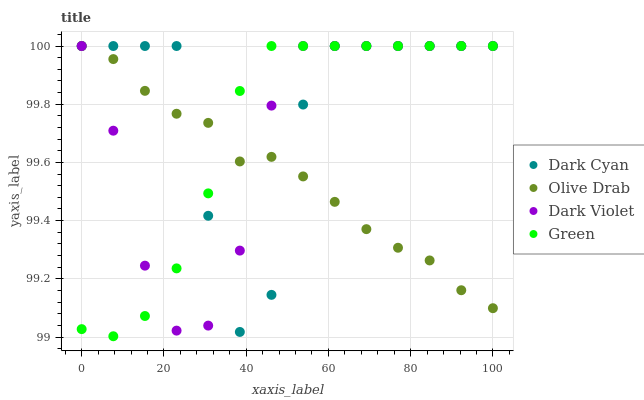Does Olive Drab have the minimum area under the curve?
Answer yes or no. Yes. Does Dark Cyan have the maximum area under the curve?
Answer yes or no. Yes. Does Green have the minimum area under the curve?
Answer yes or no. No. Does Green have the maximum area under the curve?
Answer yes or no. No. Is Olive Drab the smoothest?
Answer yes or no. Yes. Is Dark Cyan the roughest?
Answer yes or no. Yes. Is Green the smoothest?
Answer yes or no. No. Is Green the roughest?
Answer yes or no. No. Does Green have the lowest value?
Answer yes or no. Yes. Does Dark Violet have the lowest value?
Answer yes or no. No. Does Olive Drab have the highest value?
Answer yes or no. Yes. Does Green intersect Dark Violet?
Answer yes or no. Yes. Is Green less than Dark Violet?
Answer yes or no. No. Is Green greater than Dark Violet?
Answer yes or no. No. 